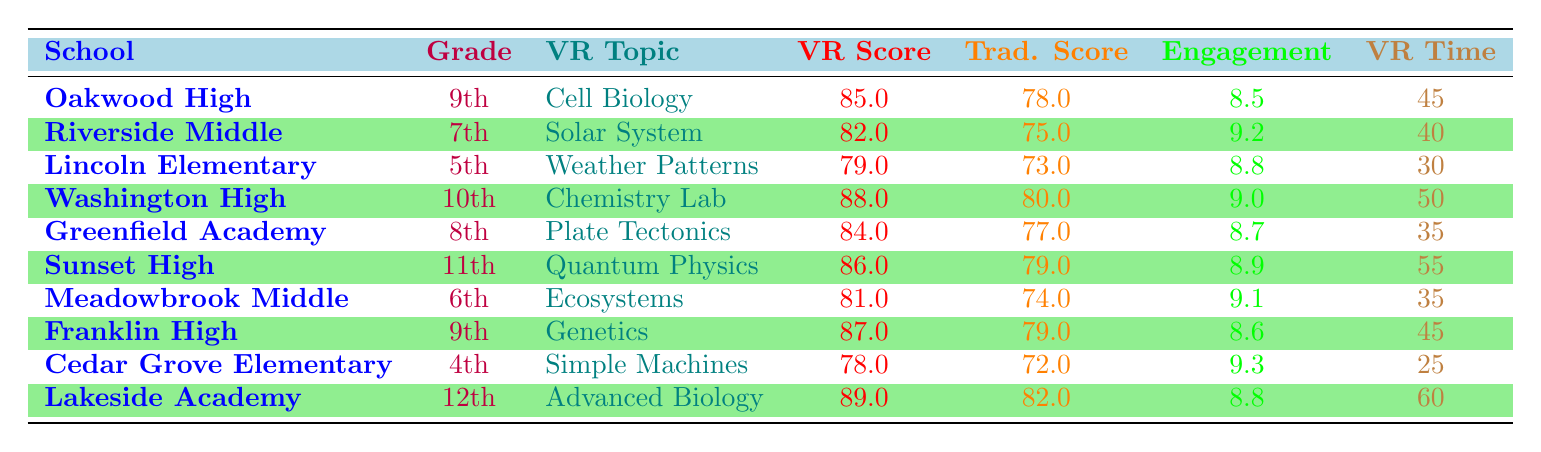What is the average test score in VR for Riverside Middle? Looking at the row for Riverside Middle, the average test score in VR is 82.
Answer: 82 Which school had the highest engagement level? From the table, Lakeside Academy has an engagement level of 8.8, which is the highest among all listed schools.
Answer: Lakeside Academy What is the difference in average test scores between VR and traditional methods for Franklin High? Franklin High has an average VR score of 87 and a traditional score of 79. The difference is 87 - 79 = 8.
Answer: 8 Does Lincoln Elementary's average VR score exceed its traditional score? Lincoln Elementary's average VR score is 79, while the traditional score is 73. Since 79 > 73, the statement is true.
Answer: Yes What is the total time spent in VR across all schools? By adding the time spent in VR for each school: 45 + 40 + 30 + 50 + 35 + 55 + 35 + 45 + 25 + 60 = 415 minutes.
Answer: 415 What is the average engagement level for grades 9 and 10? For grades 9 and 10, the engagement levels are 8.5 (Oakwood High), 8.6 (Franklin High), and 9.0 (Washington High). The average is (8.5 + 8.6 + 9.0) / 3 = 8.7.
Answer: 8.7 Is the average VR score higher for 11th grade compared to 7th grade? Sunset High in 11th grade has a VR score of 86, and Riverside Middle in 7th grade has a VR score of 82. Since 86 > 82, the statement is true.
Answer: Yes Which VR topic has the lowest average test score overall? Reviewing the scores, Simple Machines from Cedar Grove Elementary has the lowest VR score of 78.
Answer: Simple Machines What is the median average test score in VR across all schools? To find the median: first list the VR scores in ascending order: 78, 79, 81, 82, 84, 85, 86, 87, 88, 89. The median is the average of the 5th and 6th values, which are 84 and 85, so the median is (84 + 85) / 2 = 84.5.
Answer: 84.5 